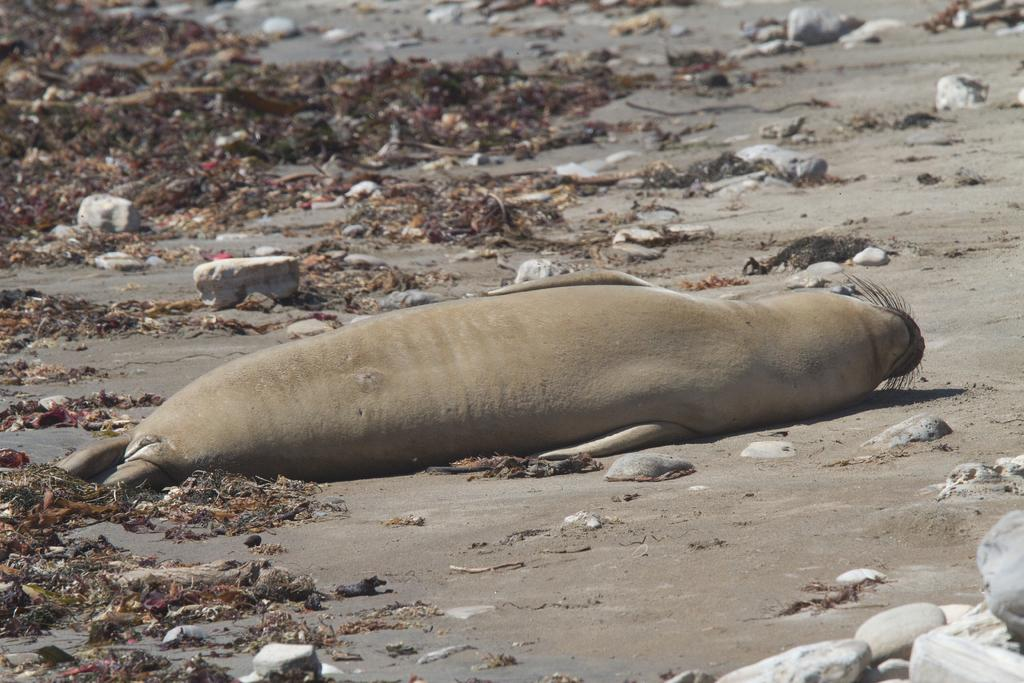What animal can be seen in the image? There is a seal in the image. What is the seal doing in the image? The seal is sleeping in the sand. What can be found around the seal in the image? There are stones around the seal. What is present on the left side top of the image? There is some waste on the left side top of the image. How many dimes are visible in the image? There are no dimes present in the image. What type of train can be seen passing by in the image? There is no train present in the image. 